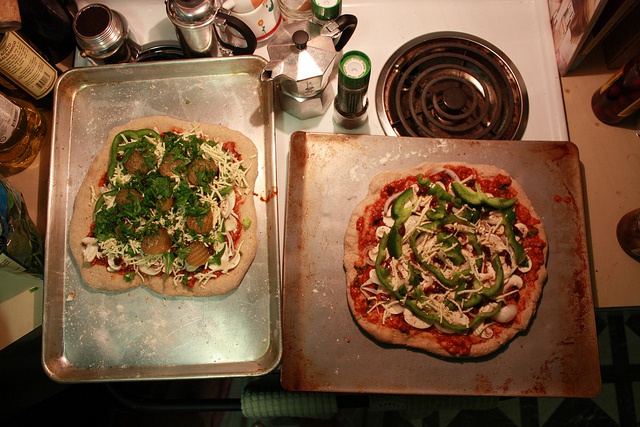Describe the objects in this image and their specific colors. I can see oven in brown, tan, black, and maroon tones, pizza in brown, maroon, black, and tan tones, pizza in brown, tan, olive, and black tones, bottle in brown, maroon, and tan tones, and bottle in brown, black, maroon, tan, and olive tones in this image. 